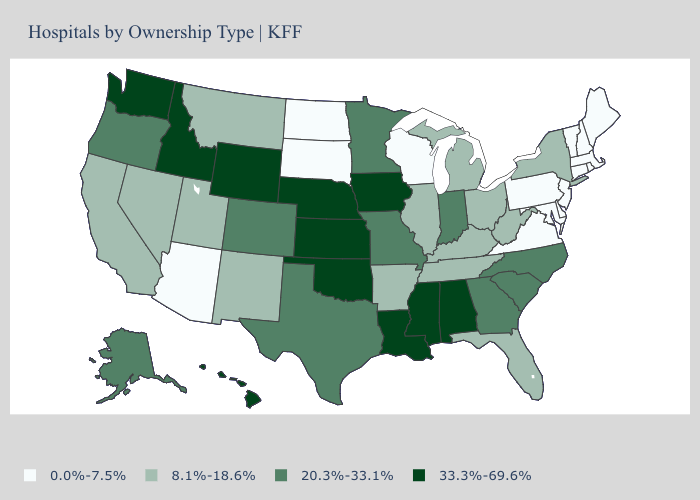How many symbols are there in the legend?
Be succinct. 4. What is the lowest value in the MidWest?
Quick response, please. 0.0%-7.5%. What is the value of Minnesota?
Concise answer only. 20.3%-33.1%. What is the value of Kansas?
Write a very short answer. 33.3%-69.6%. What is the value of Oklahoma?
Quick response, please. 33.3%-69.6%. Among the states that border Maryland , does Virginia have the highest value?
Answer briefly. No. What is the lowest value in states that border Wyoming?
Keep it brief. 0.0%-7.5%. What is the value of Indiana?
Keep it brief. 20.3%-33.1%. Among the states that border Arkansas , which have the lowest value?
Short answer required. Tennessee. Which states have the lowest value in the MidWest?
Short answer required. North Dakota, South Dakota, Wisconsin. Does Texas have the same value as Idaho?
Give a very brief answer. No. What is the lowest value in states that border Ohio?
Quick response, please. 0.0%-7.5%. Name the states that have a value in the range 0.0%-7.5%?
Answer briefly. Arizona, Connecticut, Delaware, Maine, Maryland, Massachusetts, New Hampshire, New Jersey, North Dakota, Pennsylvania, Rhode Island, South Dakota, Vermont, Virginia, Wisconsin. Name the states that have a value in the range 8.1%-18.6%?
Write a very short answer. Arkansas, California, Florida, Illinois, Kentucky, Michigan, Montana, Nevada, New Mexico, New York, Ohio, Tennessee, Utah, West Virginia. 